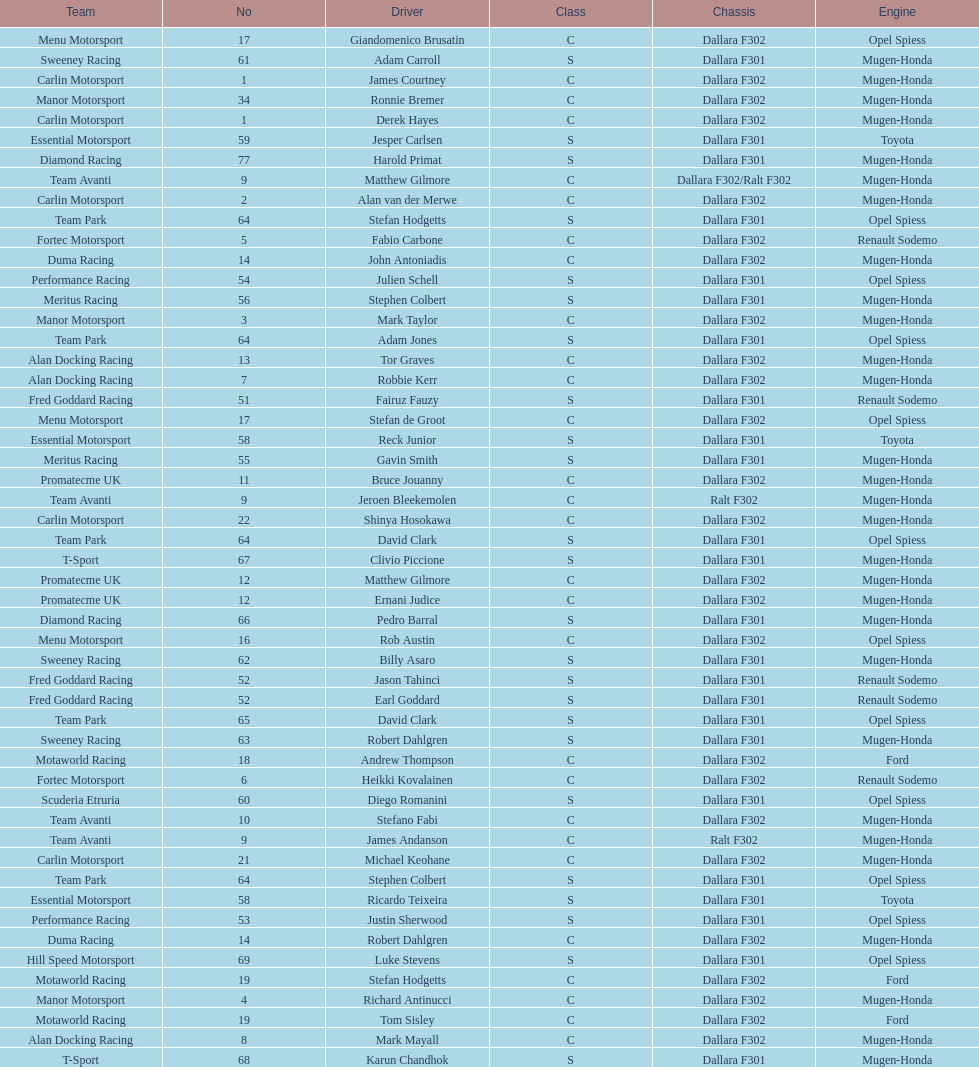What is the number of teams that had drivers all from the same country? 4. 